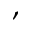<formula> <loc_0><loc_0><loc_500><loc_500>,</formula> 